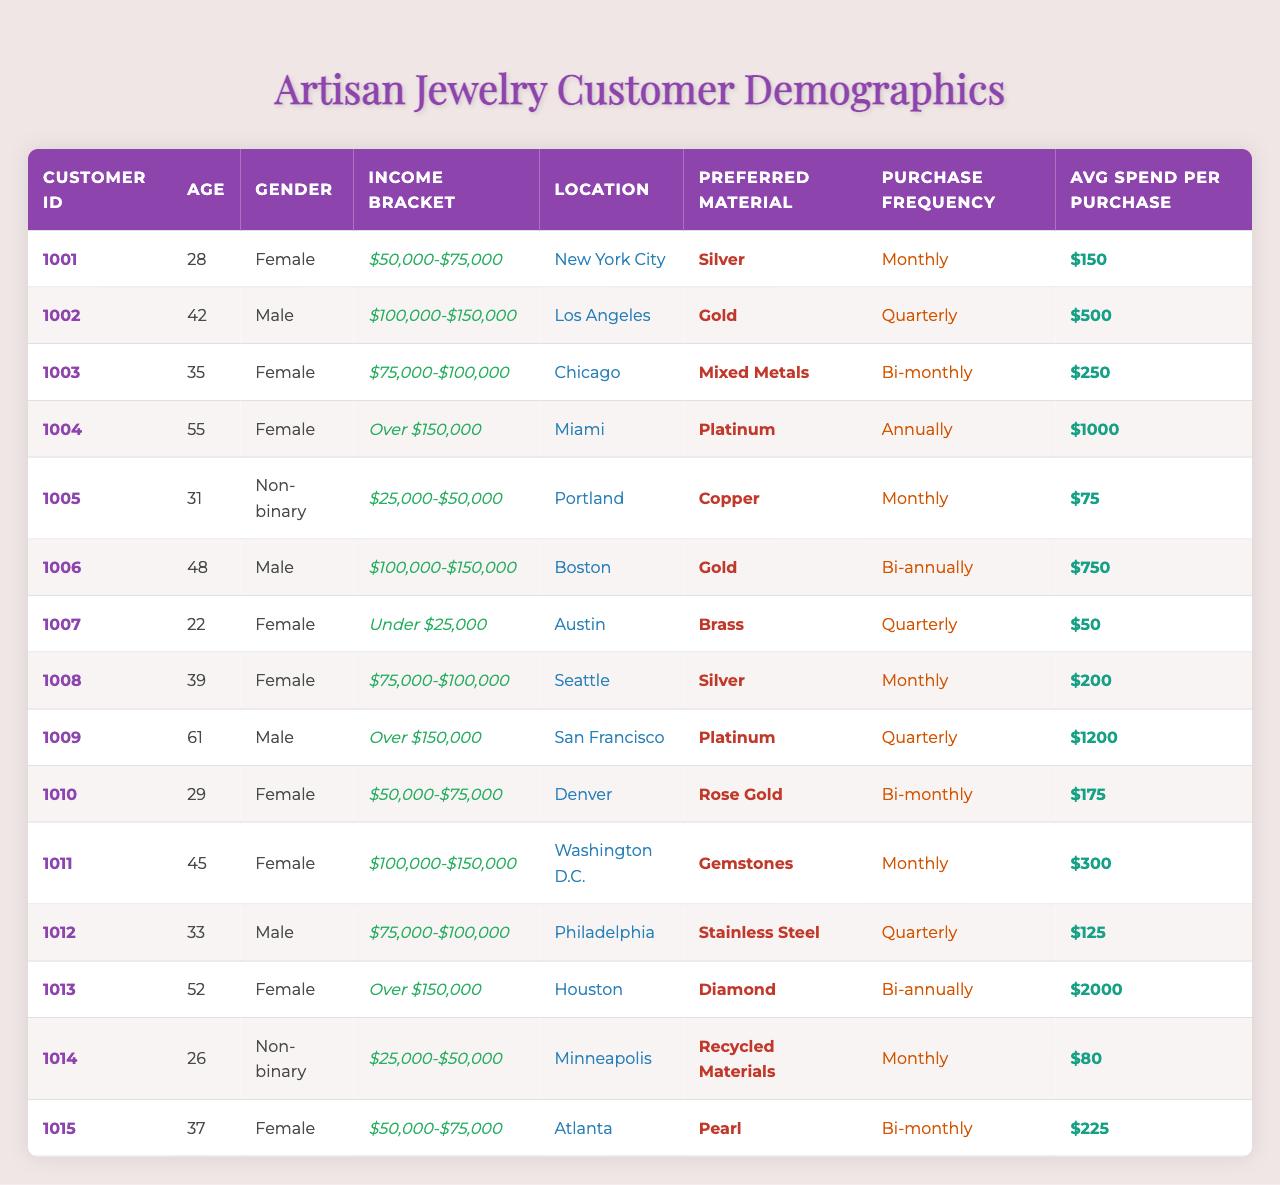What is the most common income bracket among these customers? By looking at the income bracket column, we can count how many customers fall into each bracket. The brackets are: "Under $25,000" has 2, "$25,000-$50,000" has 2, "$50,000-$75,000" has 4, "$75,000-$100,000" has 3, "$100,000-$150,000" has 3, and "Over $150,000" has 2. The bracket with the highest count is "$50,000-$75,000" with 4 customers.
Answer: $50,000-$75,000 Which gender has the highest average spend per purchase? First, we will categorize the average spend by gender: Females have spends of (150 + 250 + 1000 + 200 + 175 + 300 + 225) = 2300 over 7 individuals, so average is 2300/7 ≈ 328.57. Males have spends of (500 + 750 + 125 + 1200) = 2575 over 4 individuals, so average is 2575/4 = 643.75. The higher average spend is for males.
Answer: Male Do customers from Miami have the highest average spend per purchase? The average spend for the customer in Miami is 1000. Comparing this with other locations: New York City (150), Los Angeles (500), Chicago (250), Boston (750), San Francisco (1200), and others, San Francisco has the highest spend of 1200. Therefore, Miami does not have the highest average spend.
Answer: No Which location has the highest purchasing frequency? The highest purchasing frequency in the table is "Monthly," which occurs for 4 customers (IDs 1001, 1005, 1008, 1011). Other frequencies are "Quarterly," "Bi-monthly," "Bi-annually," and "Annually," making "Monthly" the most frequent.
Answer: Monthly What percentage of customers prefer gold as their material choice? There are 15 customers in total, and 3 of them (Customers 1002, 1006) prefer gold. To find the percentage: (3/15) * 100 = 20%.
Answer: 20% Is there any customer with an income bracket of "Under $25,000" who has a preference for silver? Looking at the data, the customer with ID 1007 has an income bracket of "Under $25,000," and their preferred material is brass, not silver. Therefore, no customer meets the criteria.
Answer: No Calculate the average age of customers who prefer recycled materials. There is only one customer who prefers recycled materials (ID 1014) and their age is 26. Therefore, the average age is 26 since there is only one data point.
Answer: 26 How does the average spend per purchase vary across different income brackets? For each income bracket, we calculate the average spend: Under $25,000 = 50 (1 customer), $25,000-$50,000 = (75 + 80)/2 = 77.5 (2 customers), $50,000-$75,000 = (150 + 175 + 225)/3 = 183.33 (4), $75,000-$100,000 = (250 + 200 + 125)/3 = 191.67 (3), $100,000-$150,000 = (500 + 750 + 300)/3 = 350 (3), Over $150,000 = (1000 + 1200 + 2000)/3 = 1400 (3). So, the averages differ quite a bit, peaking at Over $150,000.
Answer: Varies, max is Over $150,000 Which gender has the lowest average spend per purchase? Similar to previous calculations, females' average spend is approximately 328.57, while males’ average is 643.75. Thus, females have the lower average spend.
Answer: Female What is the most frequently preferred material among all customers? We can tally the preferred materials: Silver (3), Gold (3), Mixed Metals (1), Platinum (3), Copper (1), Brass (1), Rose Gold (1), Gemstones (1), Stainless Steel (1), Diamonds (1), and Recycled Materials (1). Silver, Gold, and Platinum are tied with 3 each being the most frequent.
Answer: Silver, Gold, Platinum 